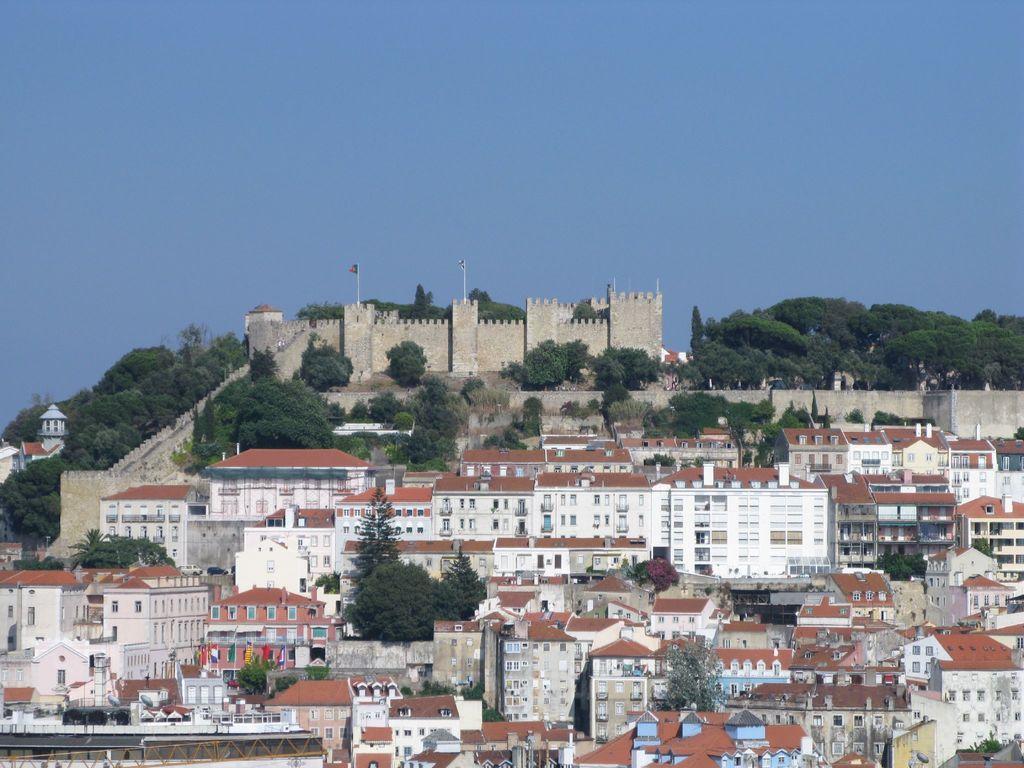Could you give a brief overview of what you see in this image? To the bottom of the image there are many buildings with roofs, windows, walls and pillars. And also there are many trees. In the middle of the image there is a fort with walls and poles with flags. Beside the fort there are many trees. To the top of the image there is a sky. 